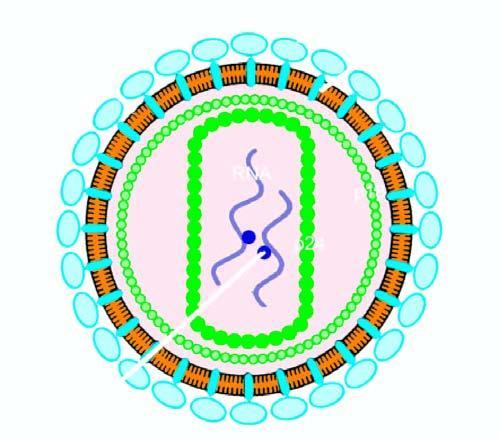what is bilayer lipid membrane studded with?
Answer the question using a single word or phrase. 2 viral glycoproteins 